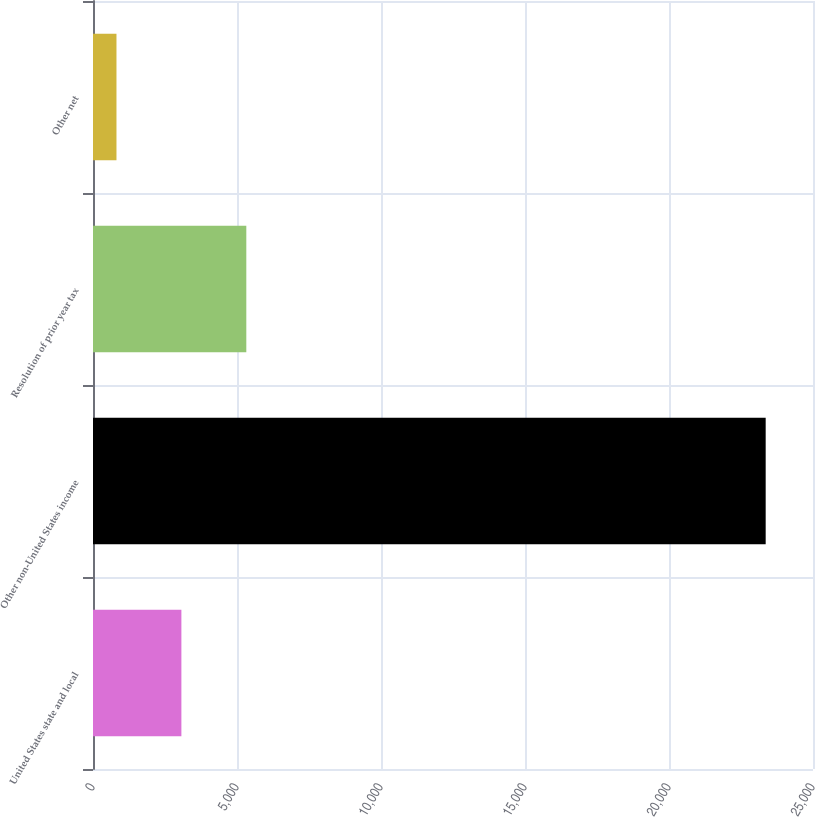<chart> <loc_0><loc_0><loc_500><loc_500><bar_chart><fcel>United States state and local<fcel>Other non-United States income<fcel>Resolution of prior year tax<fcel>Other net<nl><fcel>3069.2<fcel>23357<fcel>5323.4<fcel>815<nl></chart> 